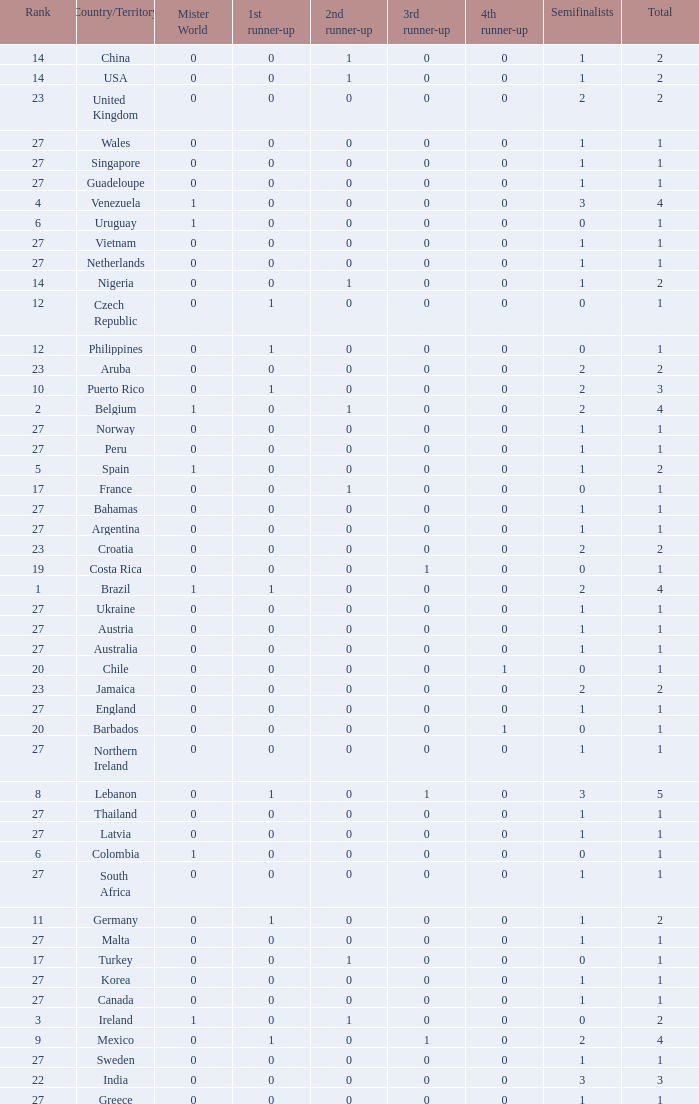How many 3rd runner up values does Turkey have? 1.0. 